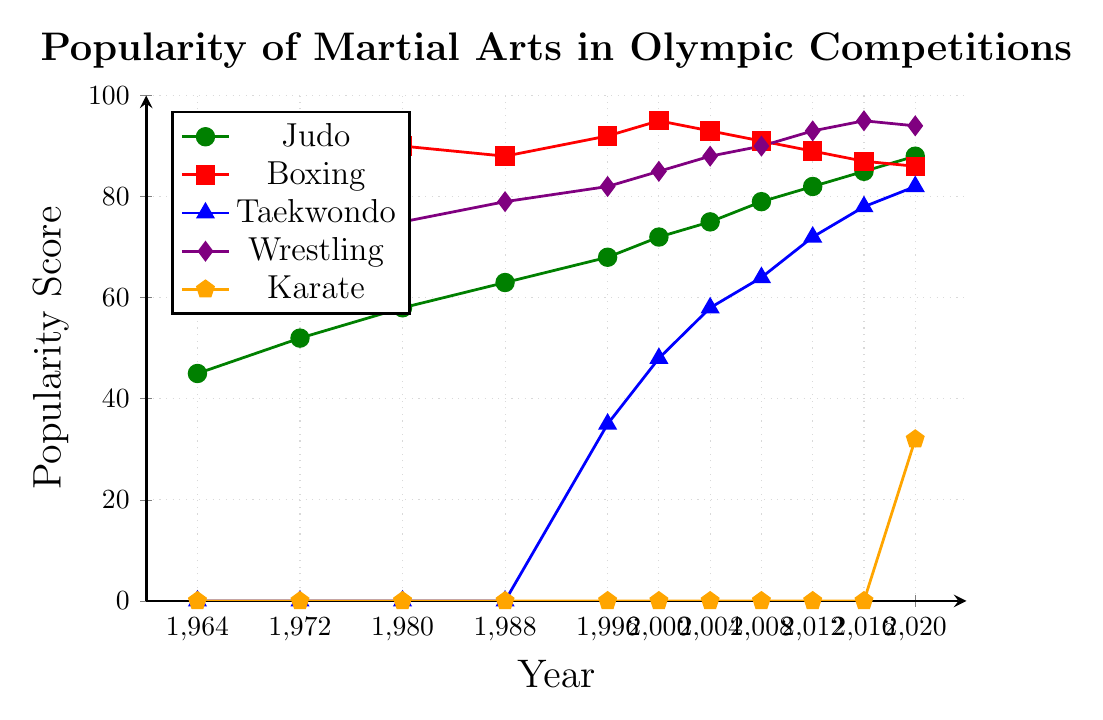Which martial art saw the highest increase in popularity from its first inclusion to 2020? Taekwondo shows the highest increase in popularity from its first inclusion in 1996 with a score of 35 to a score of 82 in 2020. This is an increase of 47 points.
Answer: Taekwondo Which martial art was the least popular in the 1980s and when? In the 1980s, Taekwondo was not yet included in the Olympics, so its popularity score was 0, making it the least popular.
Answer: Taekwondo Between boxing and wrestling, which had a higher popularity score in 2012 and by how much? In 2012, Boxing had a popularity score of 89 and Wrestling had a score of 93. Wrestling was more popular by 4 points.
Answer: 4 How did the popularity of Karate change from 2016 to 2020? Karate was not included in the Olympics until 2020, so its popularity score was 0 in 2016 and became 32 in 2020, indicating its introduction.
Answer: Increased by 32 points Which martial art was the most popular in 2000? In 2000, Boxing was the most popular with a score of 95.
Answer: Boxing What is the average popularity score of Judo across all the years shown? Summing up the Judo scores (45, 52, 58, 63, 68, 72, 75, 79, 82, 85, 88) gives 767. Dividing by the number of years (11) gives an average of approximately 69.73.
Answer: 69.73 In which years did Judo and Boxing have the same second-highest popularity scores? In 1988, Judo had a popularity score of 63 and Boxing had 88. Boxing was the second highest compared to Wrestling's 79 that year.
Answer: 1988 What is the visual color of Taekwondo on the chart? The color representing Taekwondo on the chart is blue.
Answer: Blue Calculate the overall trend for Wrestling from 1964 to 2020. How would you describe it? Wrestling shows a consistent upward trend from a popularity score of 62 in 1964 to 94 in 2020, increasing steadily over the years.
Answer: Upward trend Which two martial arts had the closest popularity scores in 2020 and what were their scores? In 2020, Boxing and Wrestling had very close popularity scores of 86 and 94, respectively.
Answer: Boxing (86) and Wrestling (94) 